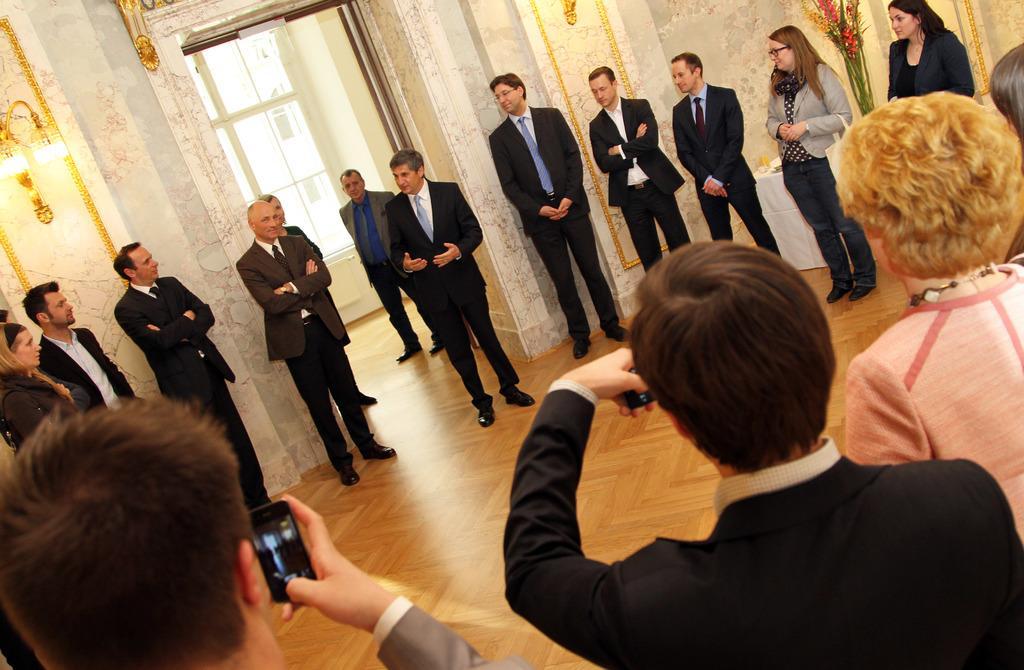Please provide a concise description of this image. A group of people are standing, they wore coats, ties, shirts, trousers, shoes. In the middle a man is standing and speaking, there are lights on either side of this entrance. On the right side 2 women are standing. 